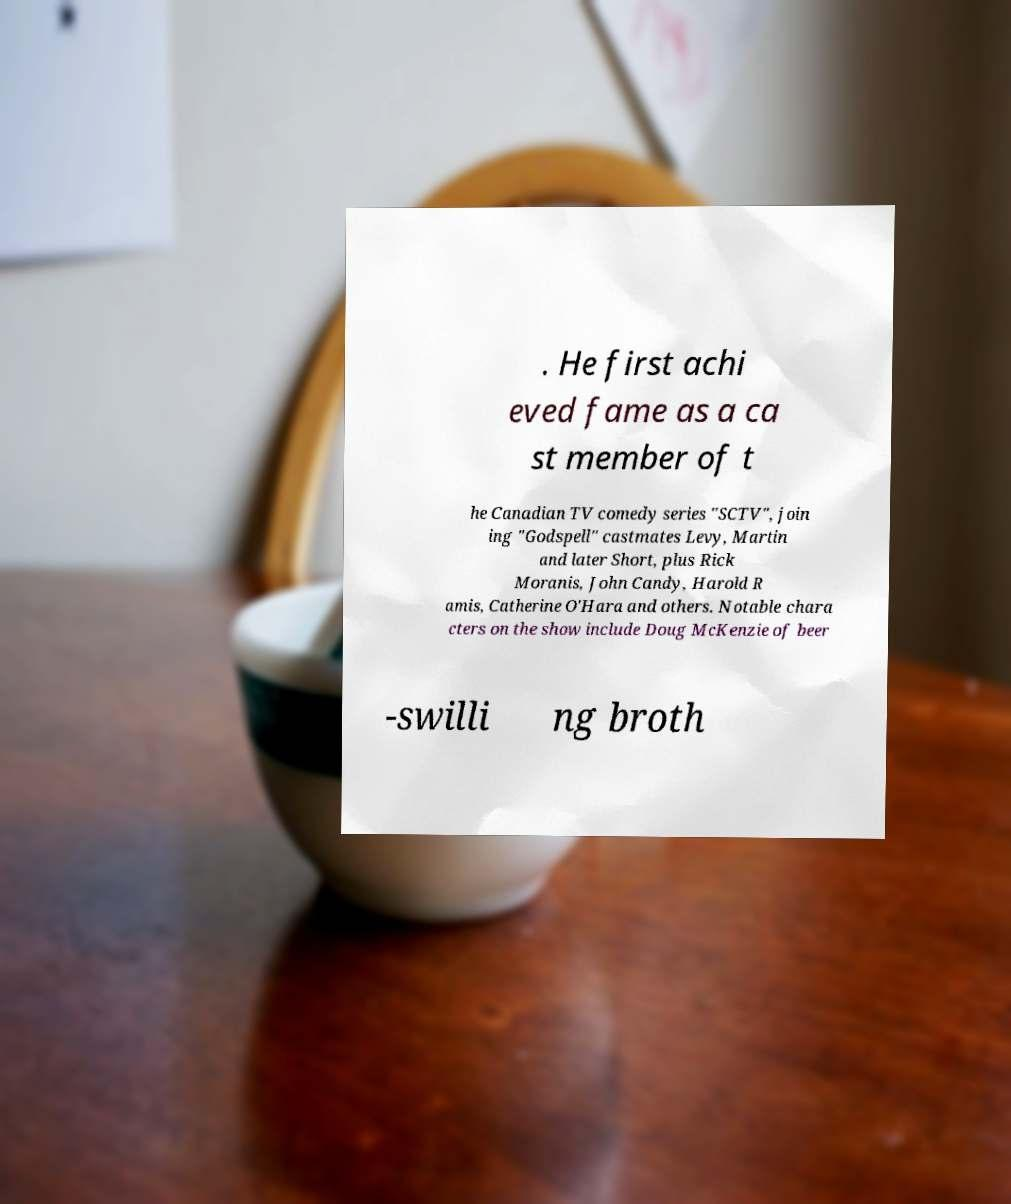Can you read and provide the text displayed in the image?This photo seems to have some interesting text. Can you extract and type it out for me? . He first achi eved fame as a ca st member of t he Canadian TV comedy series "SCTV", join ing "Godspell" castmates Levy, Martin and later Short, plus Rick Moranis, John Candy, Harold R amis, Catherine O'Hara and others. Notable chara cters on the show include Doug McKenzie of beer -swilli ng broth 